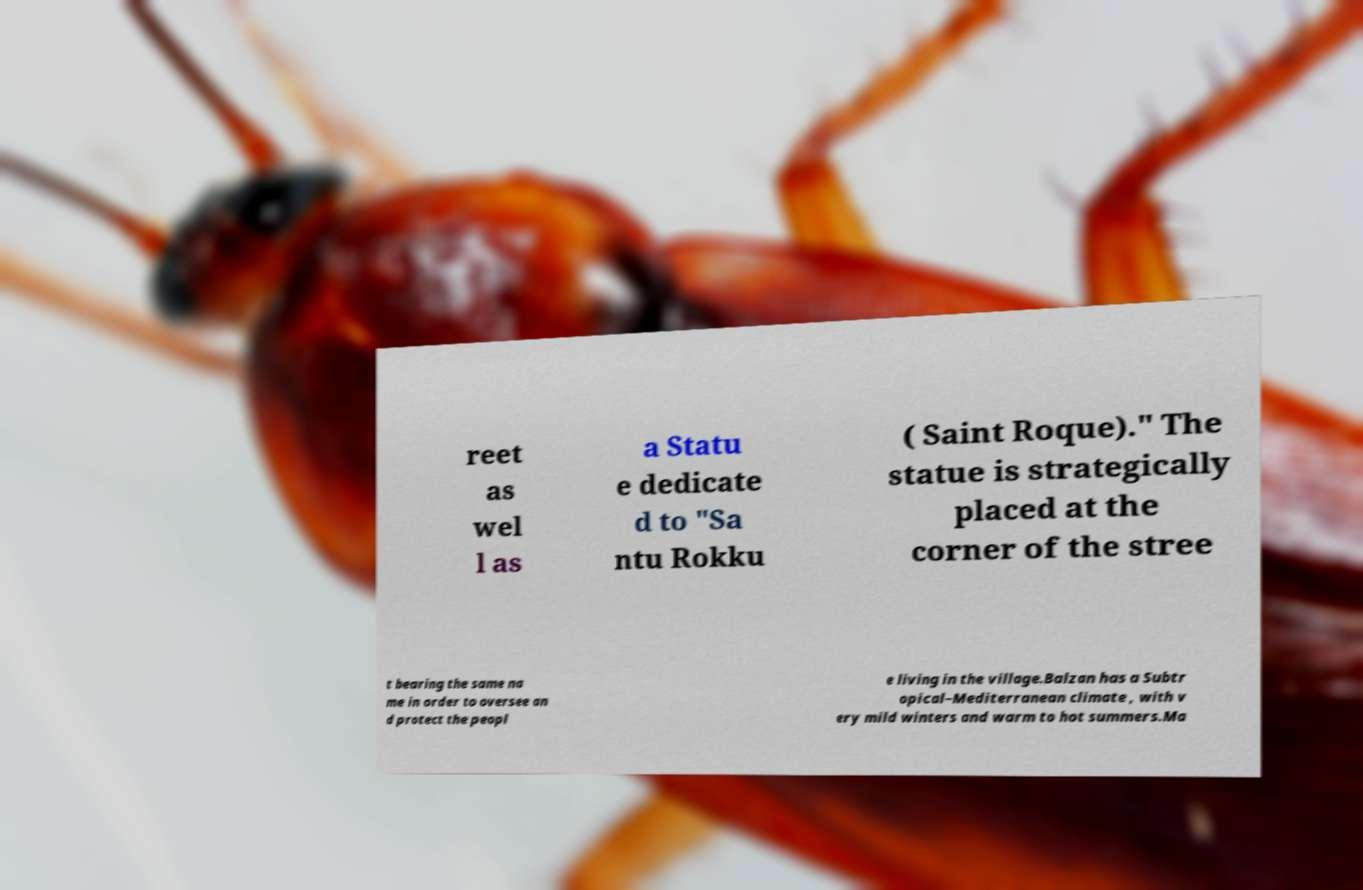Please read and relay the text visible in this image. What does it say? reet as wel l as a Statu e dedicate d to "Sa ntu Rokku ( Saint Roque)." The statue is strategically placed at the corner of the stree t bearing the same na me in order to oversee an d protect the peopl e living in the village.Balzan has a Subtr opical–Mediterranean climate , with v ery mild winters and warm to hot summers.Ma 